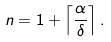<formula> <loc_0><loc_0><loc_500><loc_500>n = 1 + \left \lceil { \frac { \alpha } { \delta } } \right \rceil .</formula> 